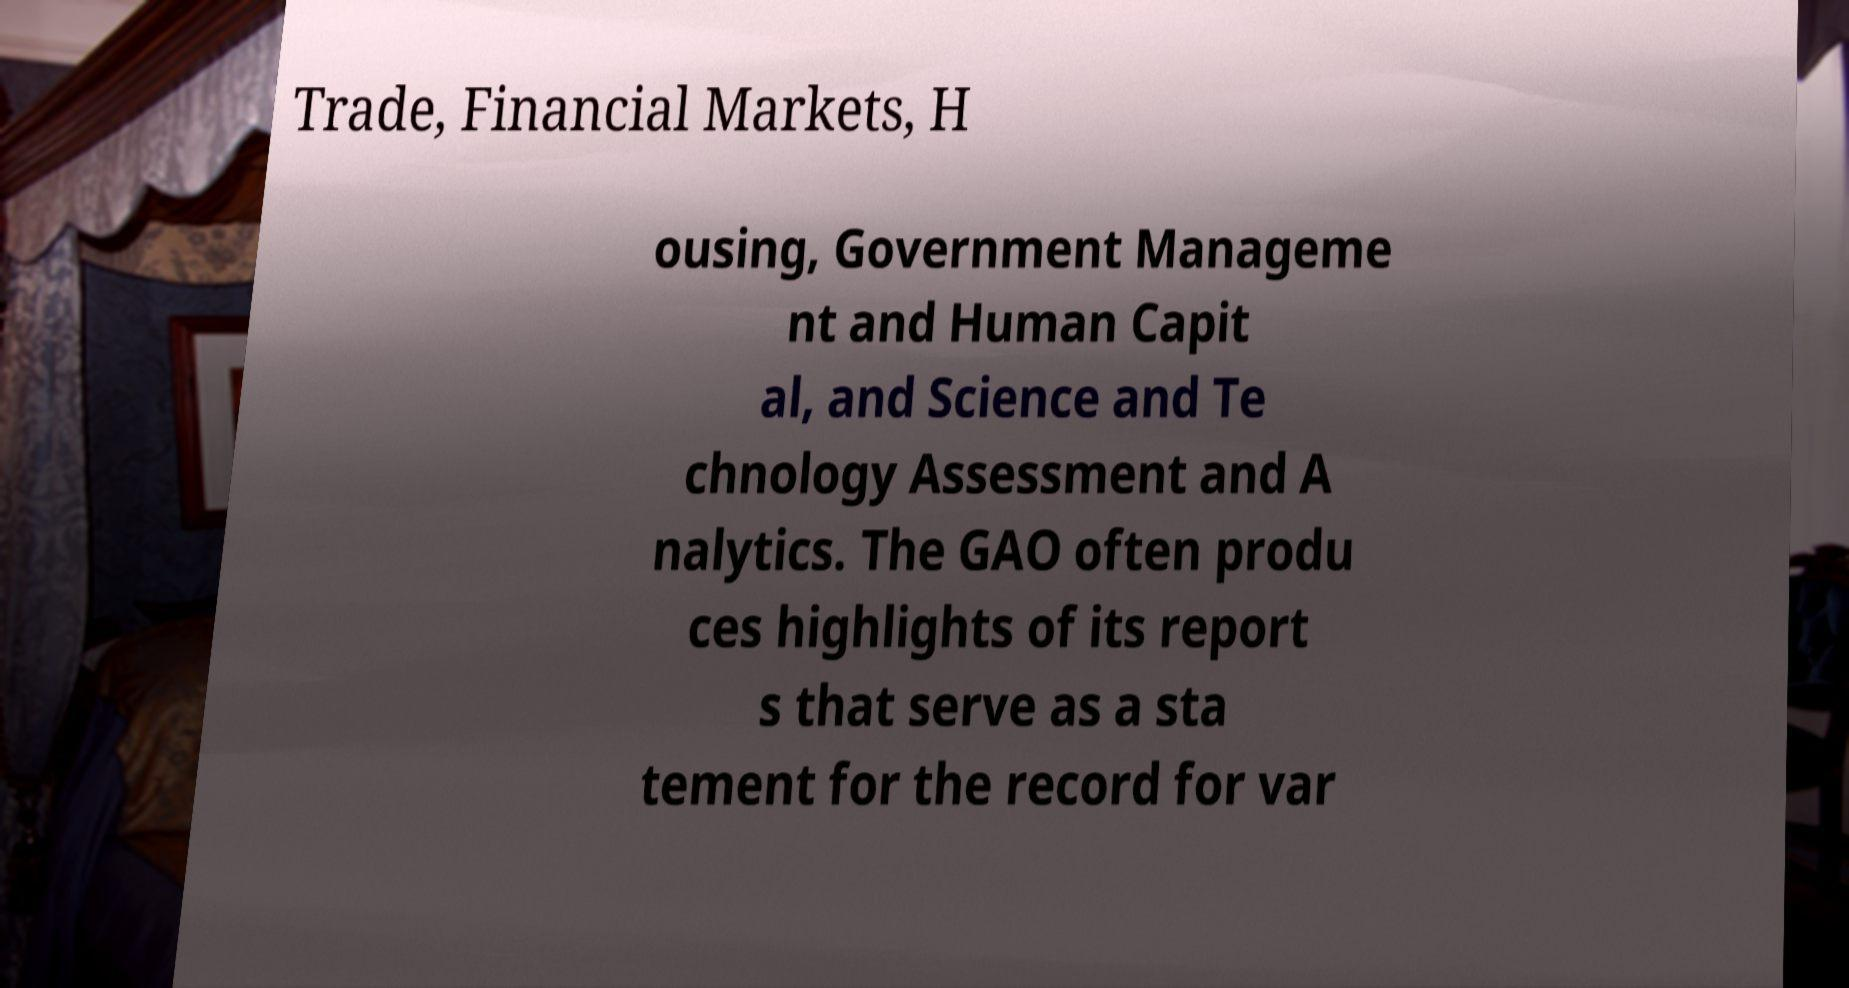For documentation purposes, I need the text within this image transcribed. Could you provide that? Trade, Financial Markets, H ousing, Government Manageme nt and Human Capit al, and Science and Te chnology Assessment and A nalytics. The GAO often produ ces highlights of its report s that serve as a sta tement for the record for var 